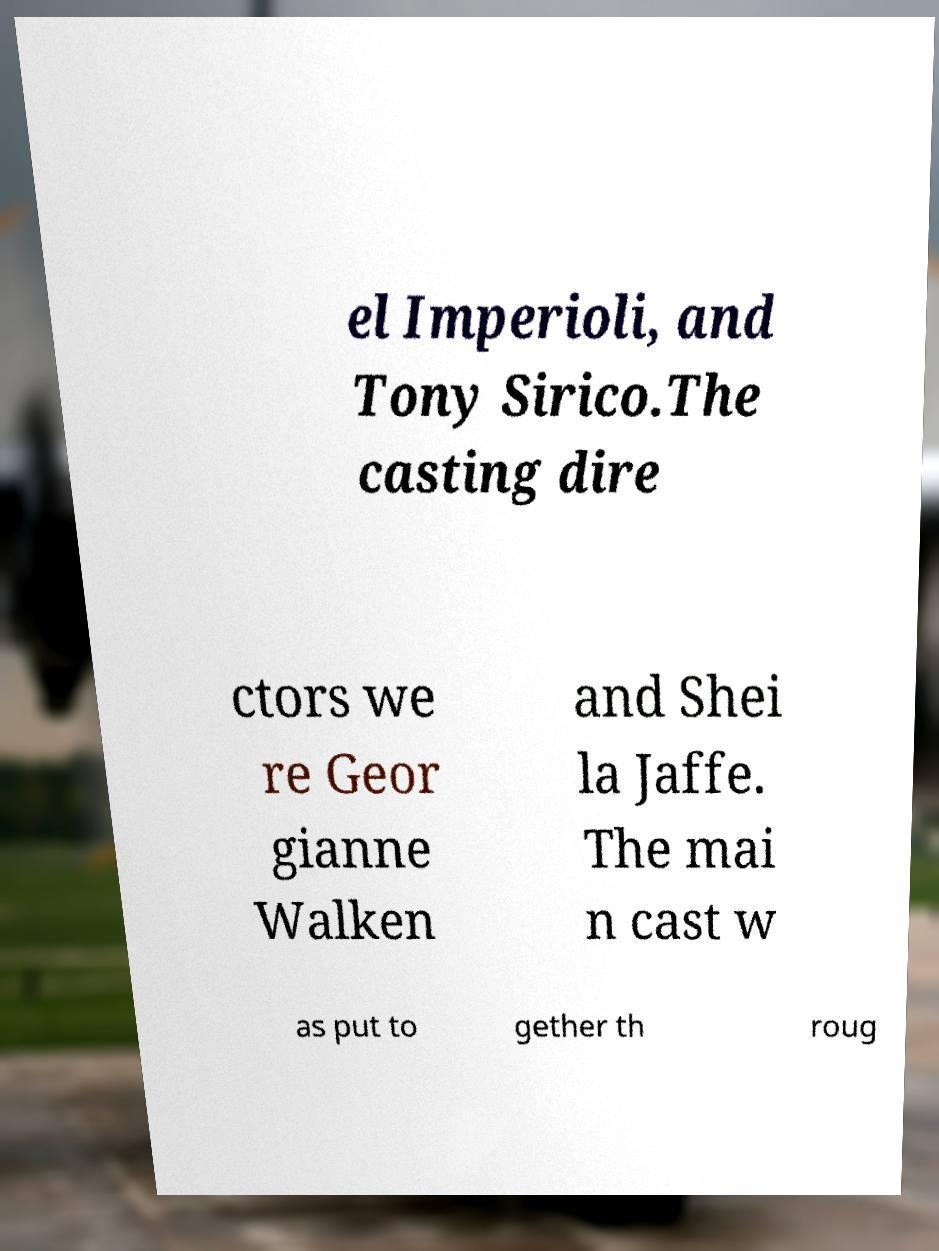Could you extract and type out the text from this image? el Imperioli, and Tony Sirico.The casting dire ctors we re Geor gianne Walken and Shei la Jaffe. The mai n cast w as put to gether th roug 